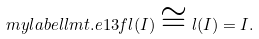Convert formula to latex. <formula><loc_0><loc_0><loc_500><loc_500>\ m y l a b e l { l m t . e 1 3 } f l ( I ) \cong l ( I ) = I .</formula> 